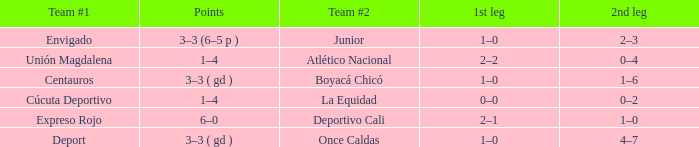What is the second part for the team #2 junior participant? 2–3. 